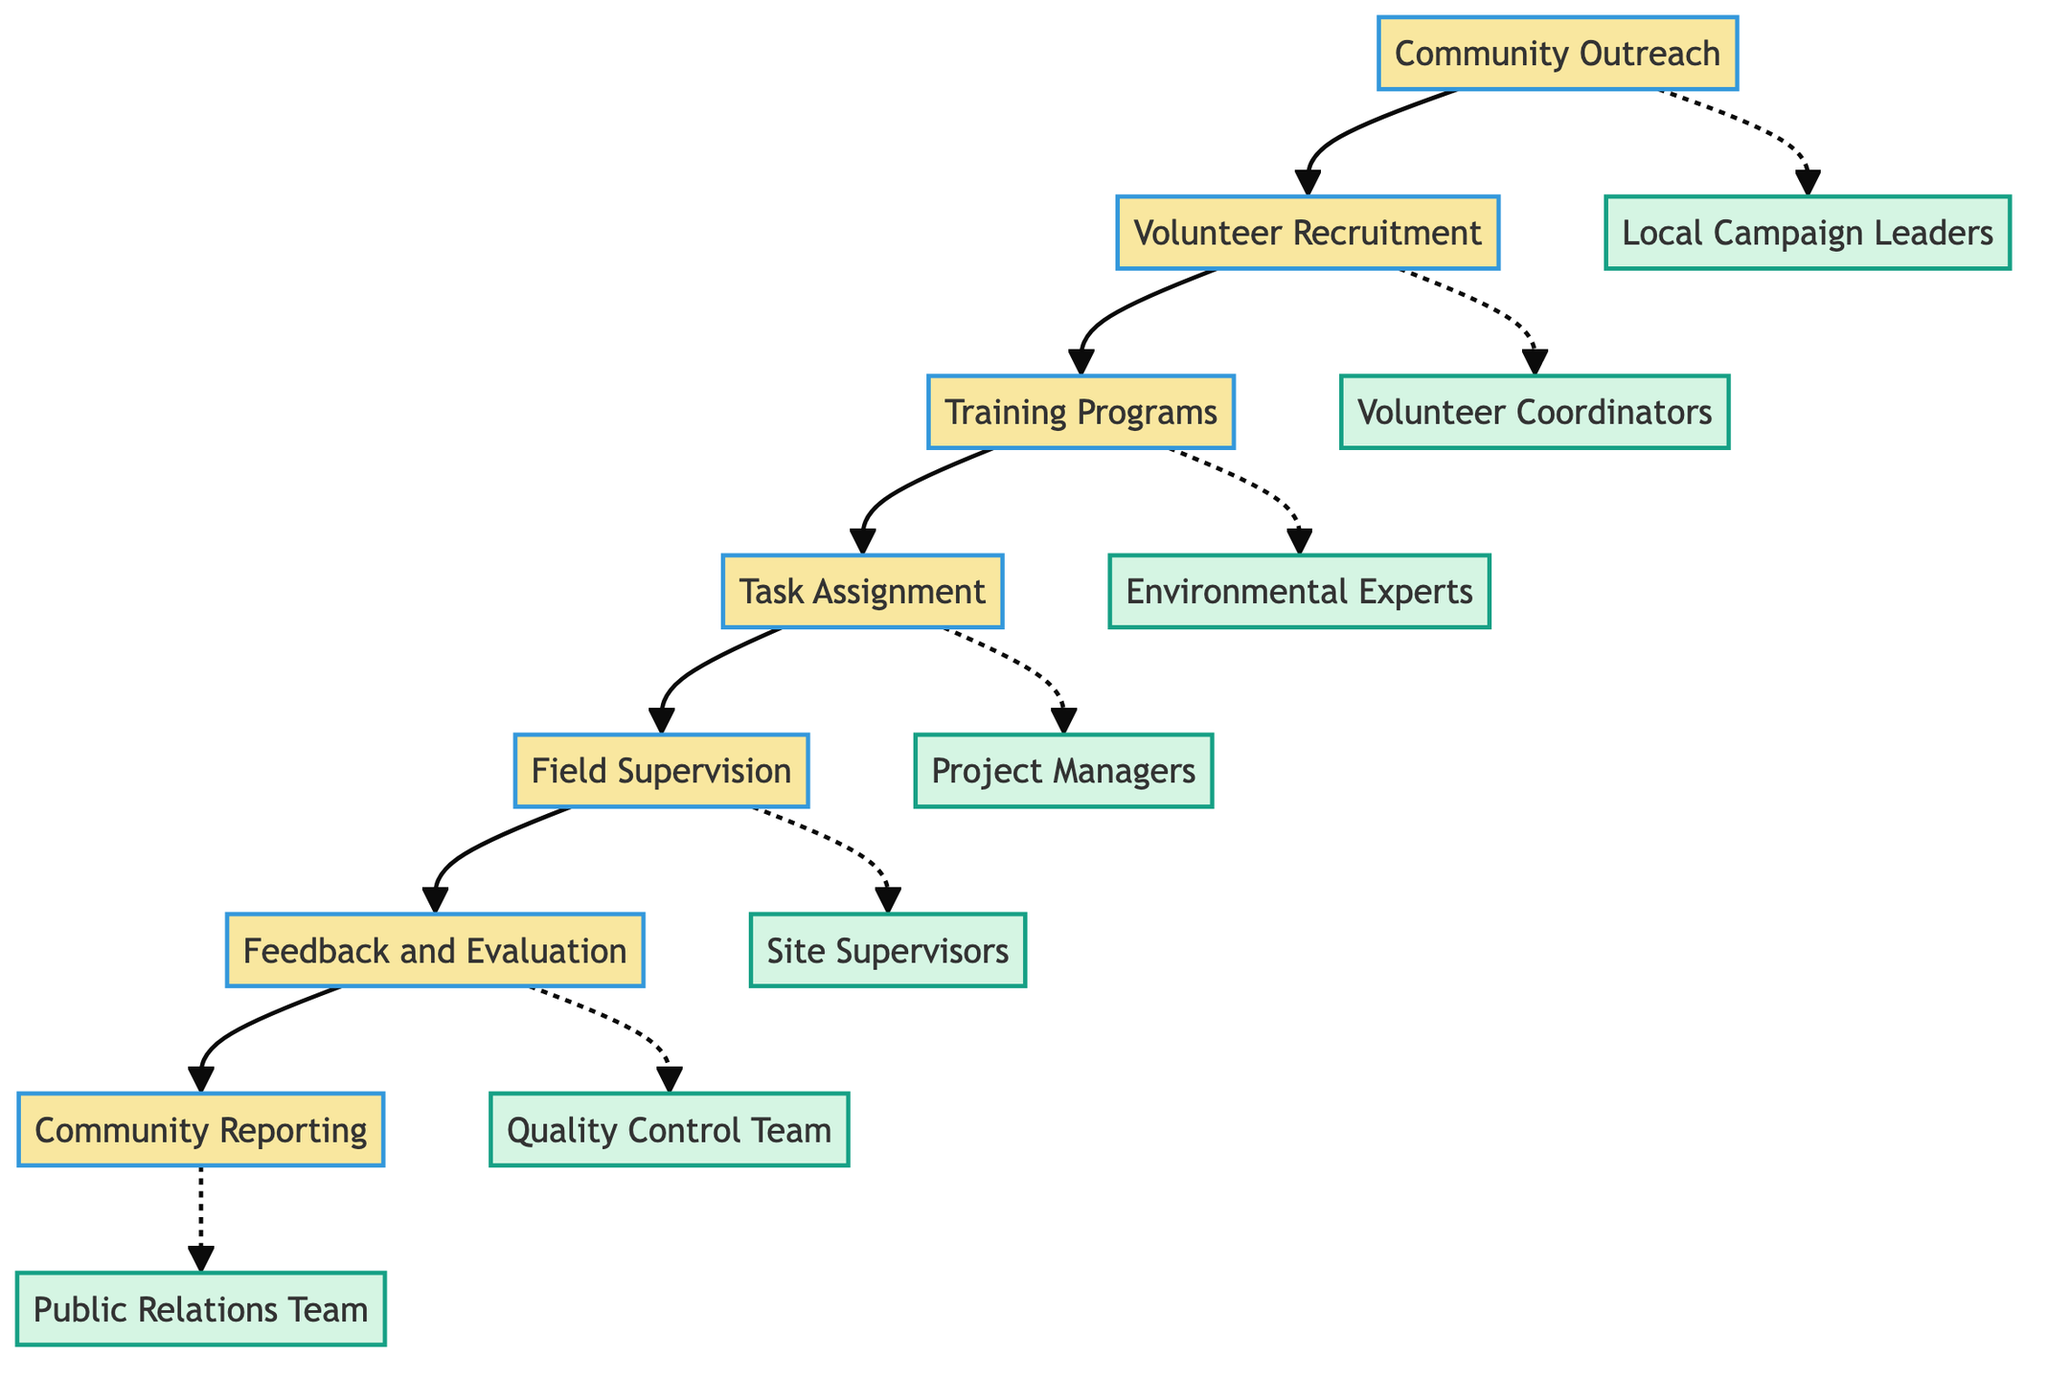What is the first step in the process flow? The diagram indicates that the process flow begins with the "Community Outreach" step.
Answer: Community Outreach Who is responsible for Volunteer Recruitment? According to the diagram, "Volunteer Coordinators" are responsible for the Volunteer Recruitment step.
Answer: Volunteer Coordinators How many steps are there in total in this process flow? By counting the distinct steps in the diagram, there are seven steps: Community Outreach, Volunteer Recruitment, Training Programs, Task Assignment, Field Supervision, Feedback and Evaluation, and Community Reporting.
Answer: 7 What action is associated with the Task Assignment step? One of the actions listed under Task Assignment in the diagram is "Create Work Schedules."
Answer: Create Work Schedules Which group conducts the background checks during Volunteer Recruitment? The diagram specifies that "Volunteer Coordinators" are responsible for conducting background checks as part of Volunteer Recruitment.
Answer: Volunteer Coordinators What is the relationship between Training Programs and Field Supervision? The flow between the steps shows that after completing Training Programs, the next step in the process is Field Supervision, indicating a sequential relationship in the process.
Answer: Sequential Which step receives feedback from volunteers? The diagram indicates that the "Feedback and Evaluation" step is responsible for collecting feedback from volunteers.
Answer: Feedback and Evaluation What is the last step in the process? The last step shown in the flow of the diagram is "Community Reporting."
Answer: Community Reporting Who prepares progress reports? The diagram assigns the responsibility for preparing progress reports to the "Public Relations Team."
Answer: Public Relations Team 